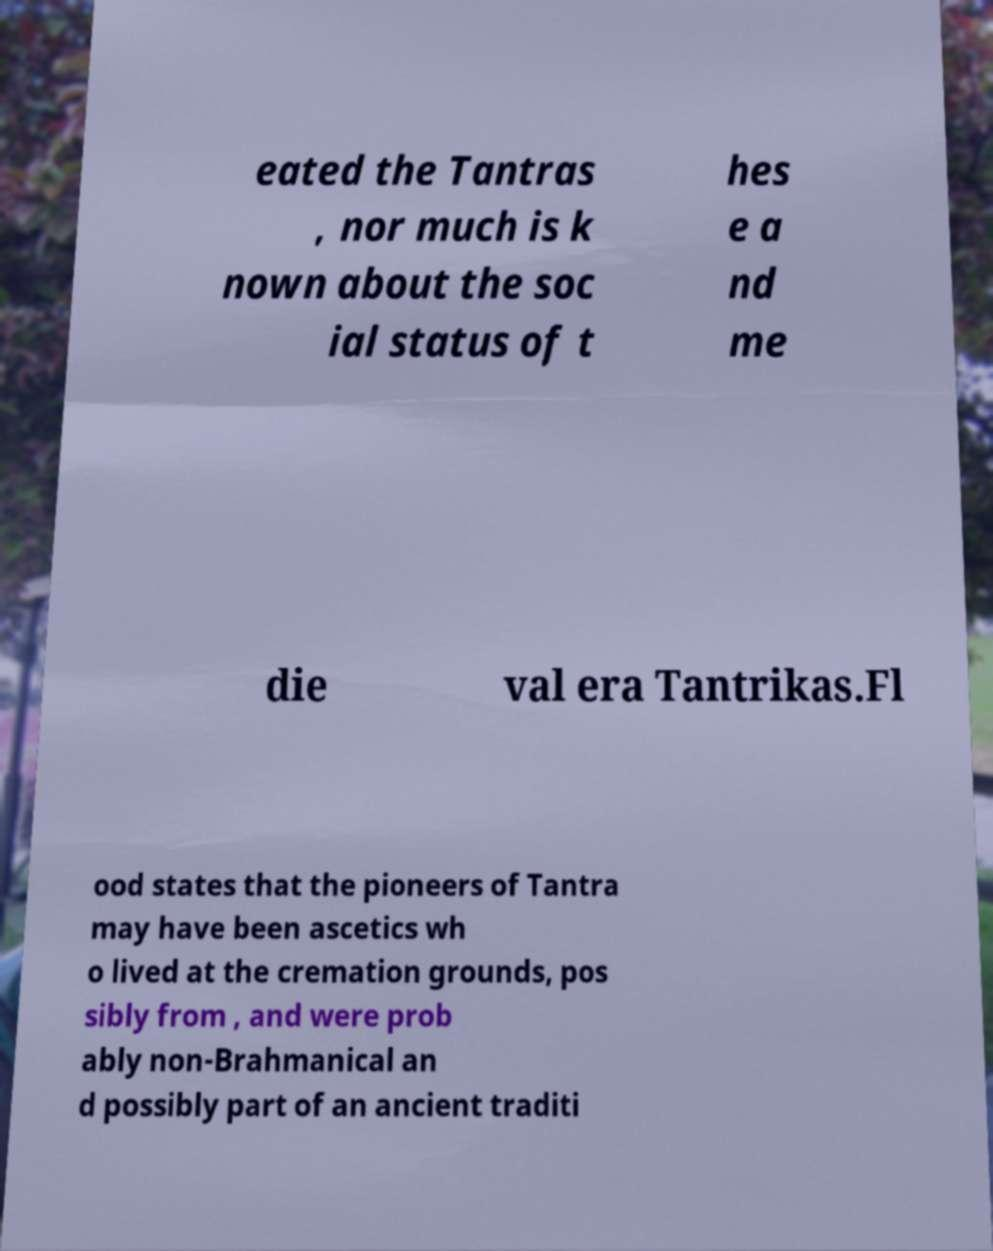I need the written content from this picture converted into text. Can you do that? eated the Tantras , nor much is k nown about the soc ial status of t hes e a nd me die val era Tantrikas.Fl ood states that the pioneers of Tantra may have been ascetics wh o lived at the cremation grounds, pos sibly from , and were prob ably non-Brahmanical an d possibly part of an ancient traditi 